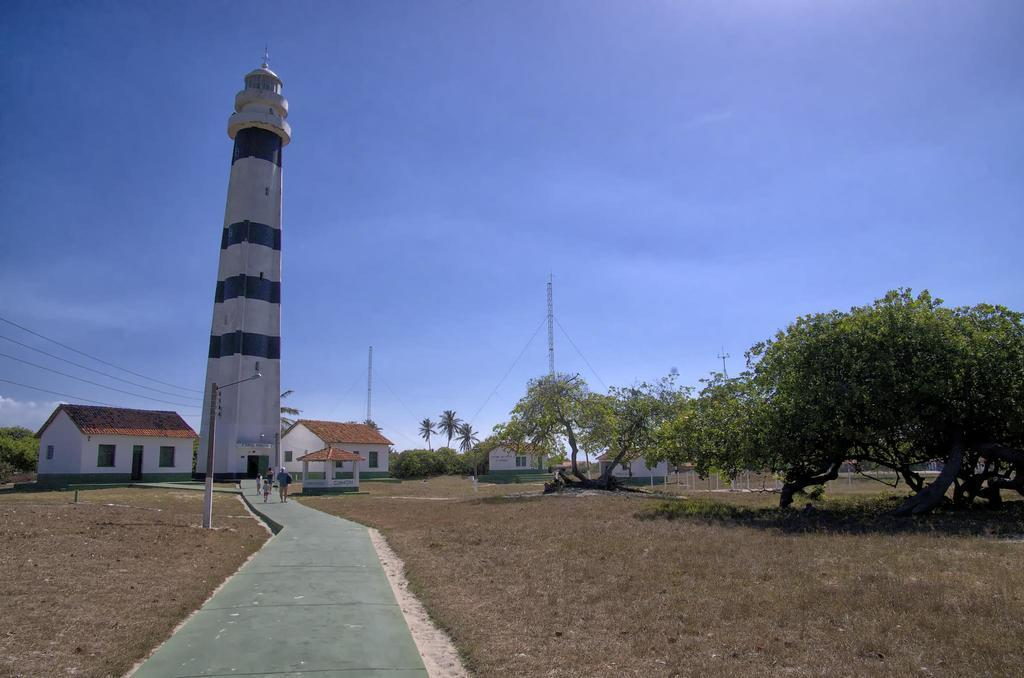What type of structures can be seen in the image? There are houses and buildings in the image. What type of vegetation is visible in the image? There is grass visible in the image. What are the people in the image doing? There are people walking in the image. What else can be seen in the image besides structures and vegetation? There are trees in the image. What else can be seen in the image besides structures, vegetation, and people? There is a current pole in the image. What is visible in the sky in the image? The sky is visible in the image. What type of knowledge is being shared between the trees in the image? There is no indication in the image that the trees are sharing knowledge, as trees do not have the ability to communicate in the way humans do. 